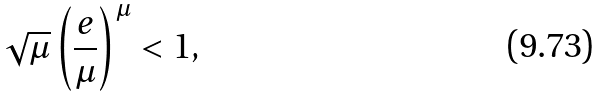<formula> <loc_0><loc_0><loc_500><loc_500>\sqrt { \mu } \left ( \frac { e } { \mu } \right ) ^ { \mu } < 1 ,</formula> 